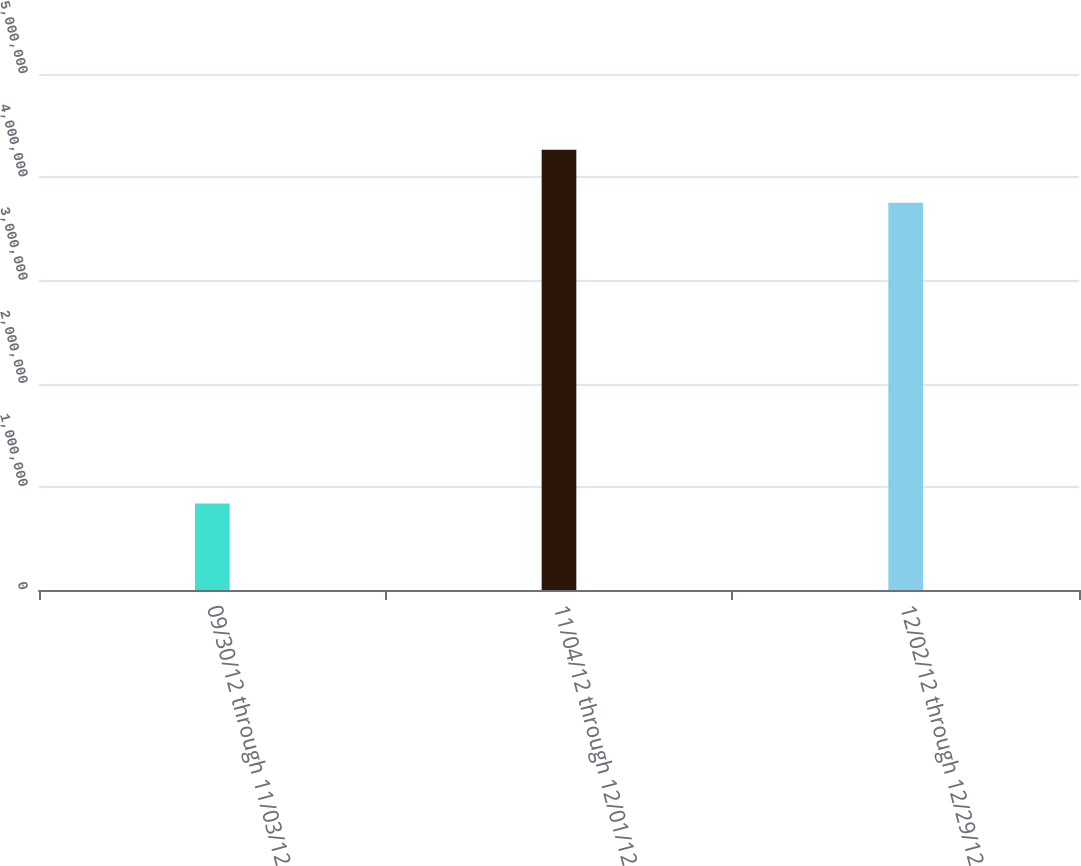Convert chart to OTSL. <chart><loc_0><loc_0><loc_500><loc_500><bar_chart><fcel>09/30/12 through 11/03/12<fcel>11/04/12 through 12/01/12<fcel>12/02/12 through 12/29/12<nl><fcel>838904<fcel>4.26524e+06<fcel>3.75332e+06<nl></chart> 